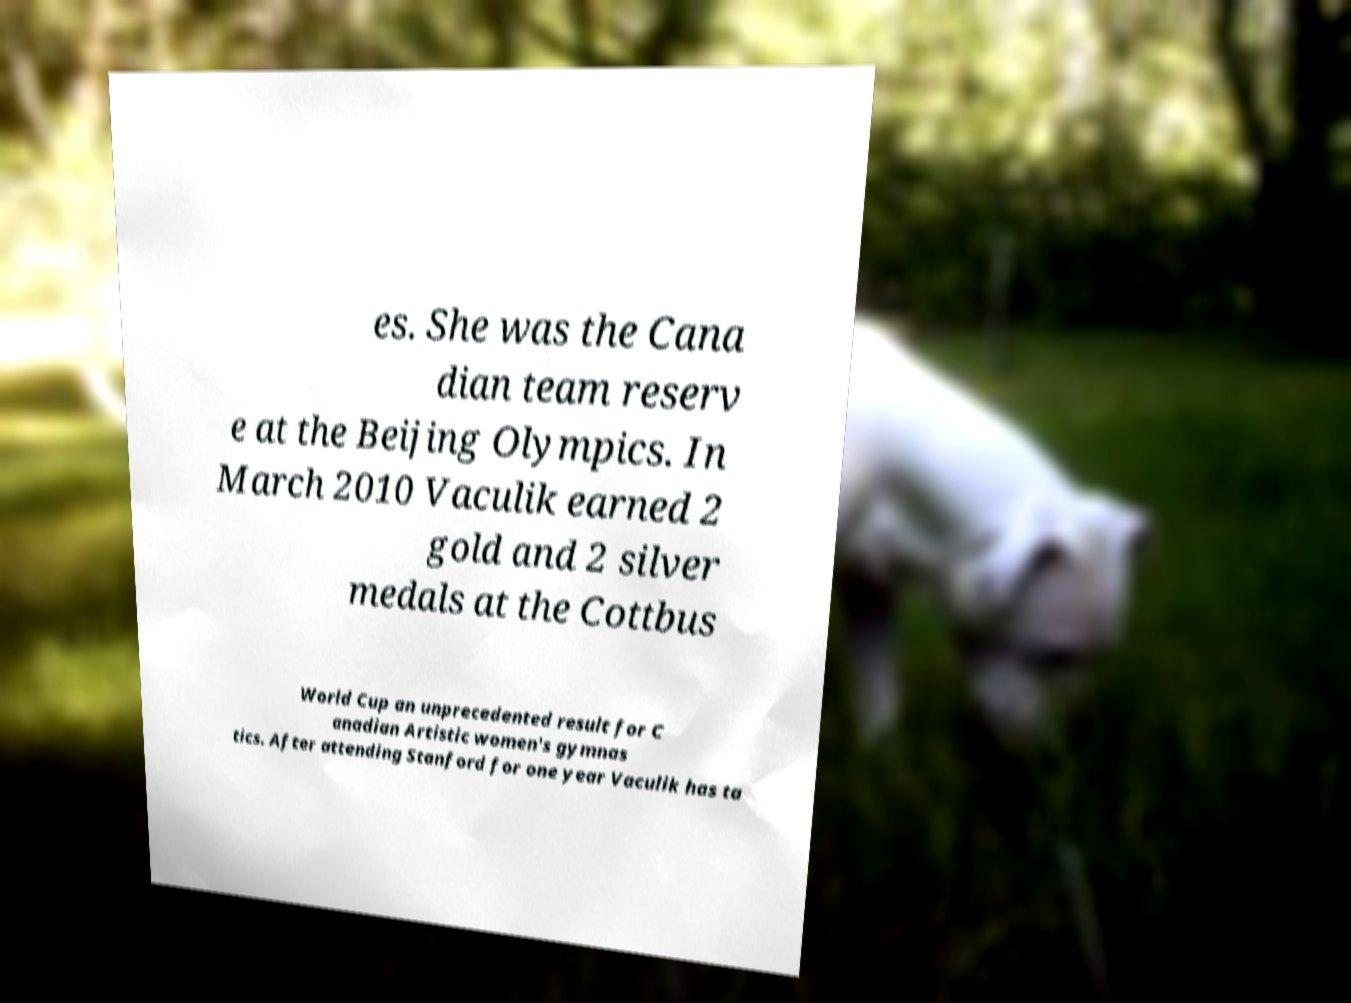What messages or text are displayed in this image? I need them in a readable, typed format. es. She was the Cana dian team reserv e at the Beijing Olympics. In March 2010 Vaculik earned 2 gold and 2 silver medals at the Cottbus World Cup an unprecedented result for C anadian Artistic women's gymnas tics. After attending Stanford for one year Vaculik has ta 